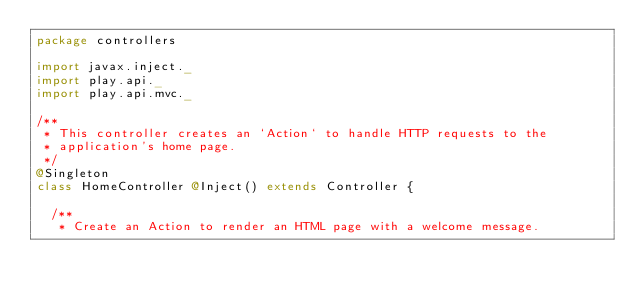<code> <loc_0><loc_0><loc_500><loc_500><_Scala_>package controllers

import javax.inject._
import play.api._
import play.api.mvc._

/**
 * This controller creates an `Action` to handle HTTP requests to the
 * application's home page.
 */
@Singleton
class HomeController @Inject() extends Controller {

  /**
   * Create an Action to render an HTML page with a welcome message.</code> 